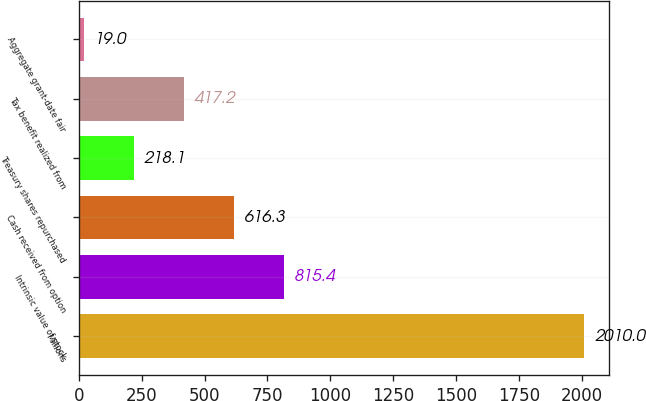Convert chart. <chart><loc_0><loc_0><loc_500><loc_500><bar_chart><fcel>Millions<fcel>Intrinsic value of stock<fcel>Cash received from option<fcel>Treasury shares repurchased<fcel>Tax benefit realized from<fcel>Aggregate grant-date fair<nl><fcel>2010<fcel>815.4<fcel>616.3<fcel>218.1<fcel>417.2<fcel>19<nl></chart> 